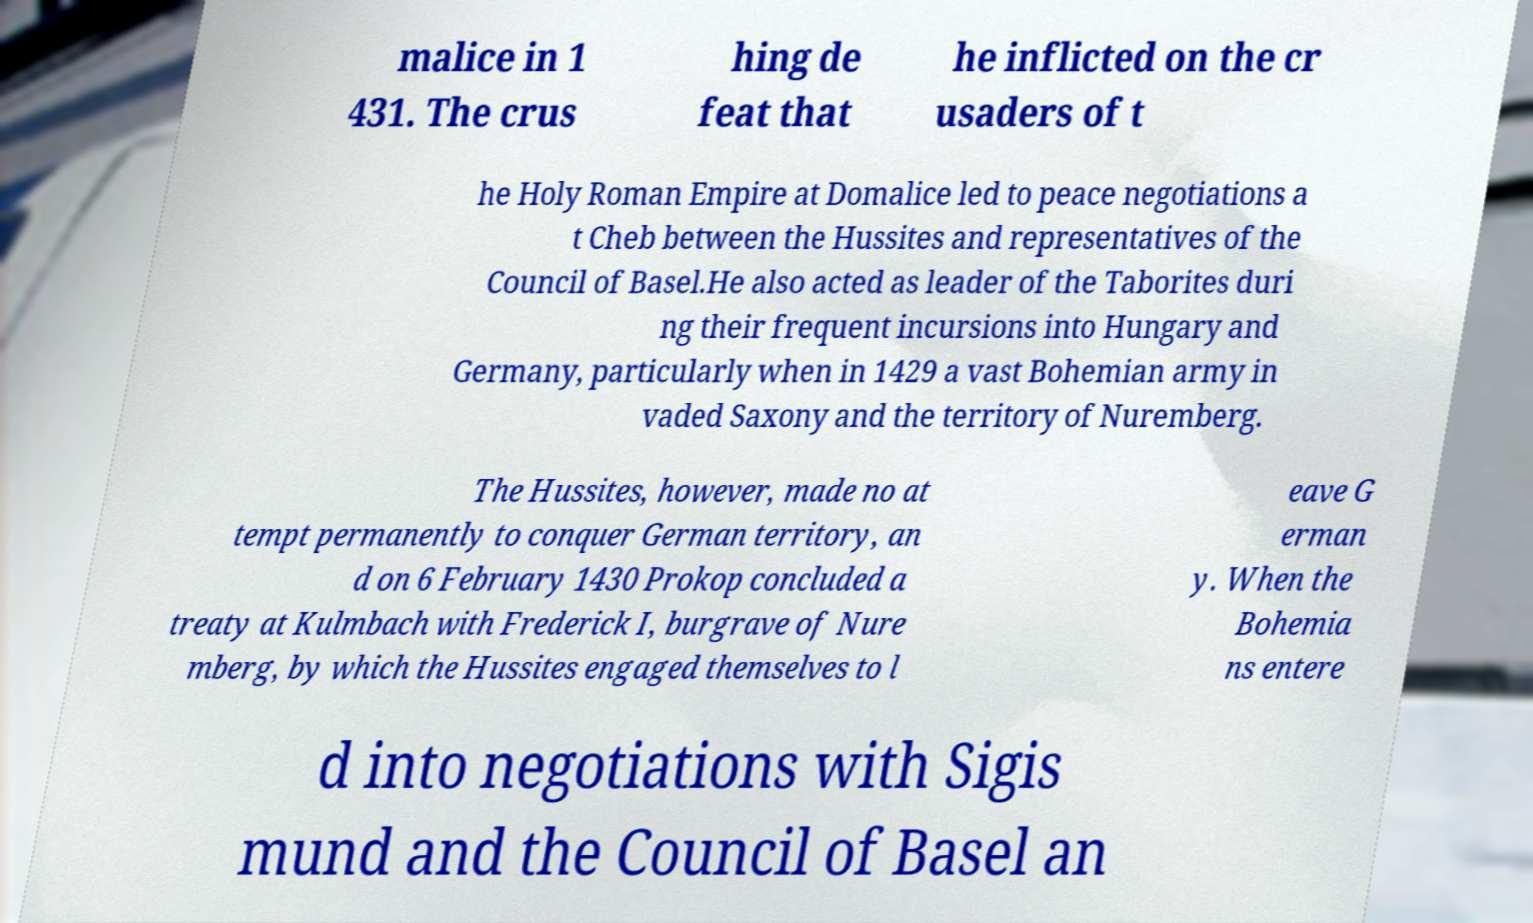Could you assist in decoding the text presented in this image and type it out clearly? malice in 1 431. The crus hing de feat that he inflicted on the cr usaders of t he Holy Roman Empire at Domalice led to peace negotiations a t Cheb between the Hussites and representatives of the Council of Basel.He also acted as leader of the Taborites duri ng their frequent incursions into Hungary and Germany, particularly when in 1429 a vast Bohemian army in vaded Saxony and the territory of Nuremberg. The Hussites, however, made no at tempt permanently to conquer German territory, an d on 6 February 1430 Prokop concluded a treaty at Kulmbach with Frederick I, burgrave of Nure mberg, by which the Hussites engaged themselves to l eave G erman y. When the Bohemia ns entere d into negotiations with Sigis mund and the Council of Basel an 